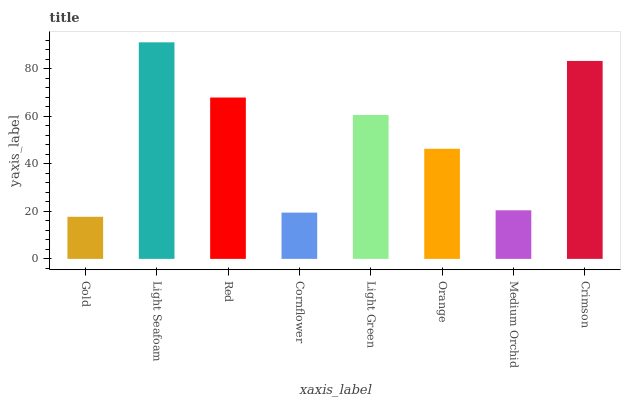Is Gold the minimum?
Answer yes or no. Yes. Is Light Seafoam the maximum?
Answer yes or no. Yes. Is Red the minimum?
Answer yes or no. No. Is Red the maximum?
Answer yes or no. No. Is Light Seafoam greater than Red?
Answer yes or no. Yes. Is Red less than Light Seafoam?
Answer yes or no. Yes. Is Red greater than Light Seafoam?
Answer yes or no. No. Is Light Seafoam less than Red?
Answer yes or no. No. Is Light Green the high median?
Answer yes or no. Yes. Is Orange the low median?
Answer yes or no. Yes. Is Red the high median?
Answer yes or no. No. Is Crimson the low median?
Answer yes or no. No. 